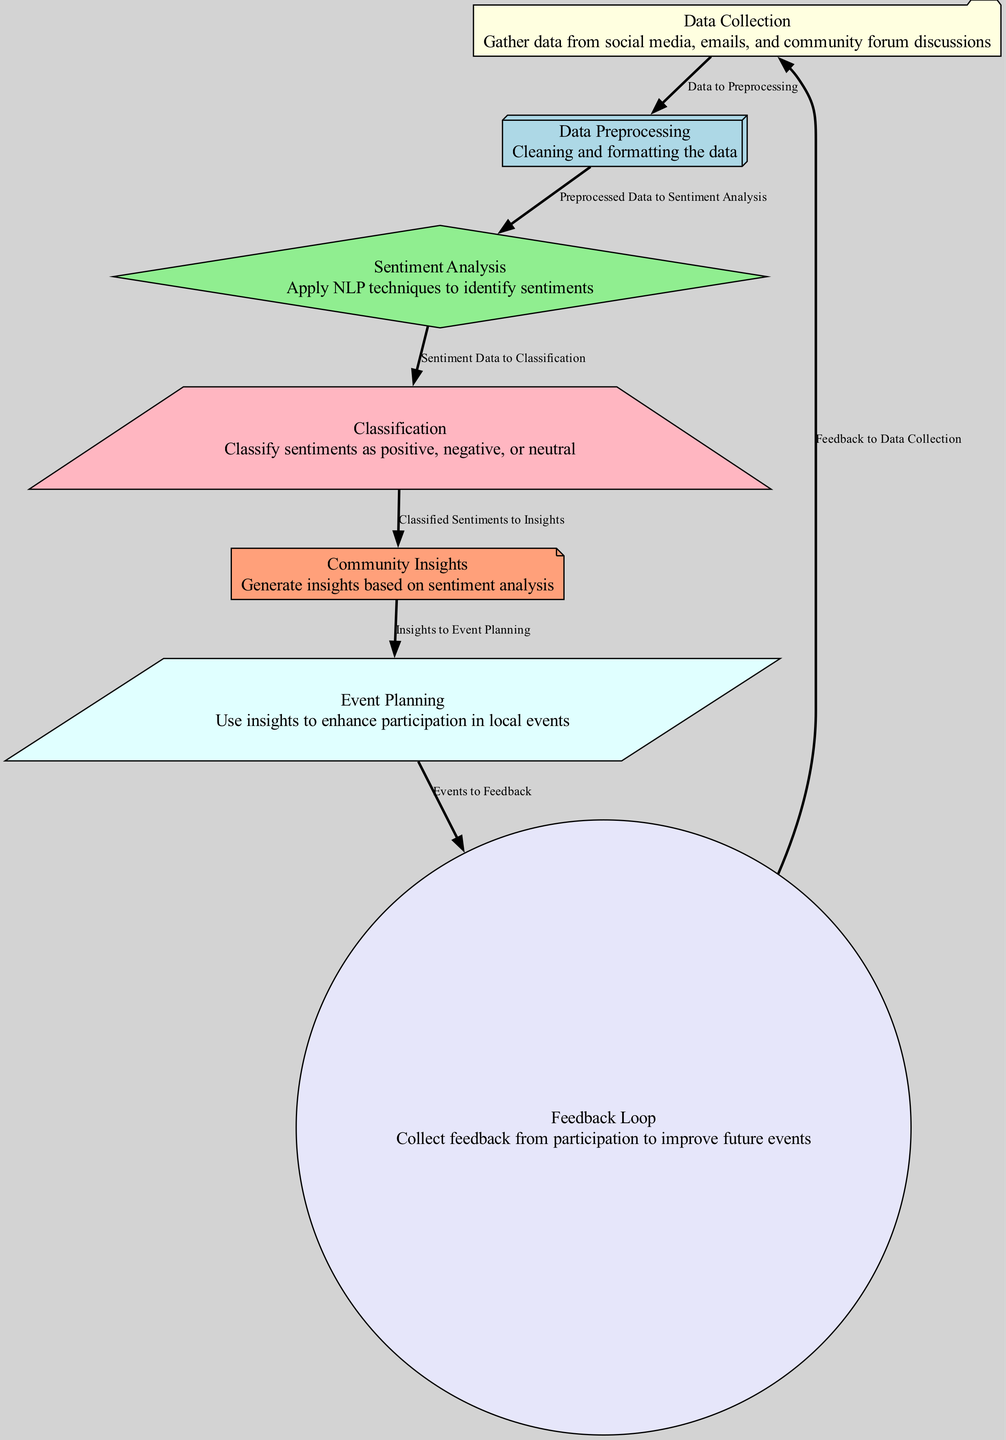What is the first step in the process? The diagram lists the first node as "Data Collection," indicating that the first action is to gather data.
Answer: Data Collection How many nodes are in the diagram? By counting all the distinct elements labeled in the diagram, we find there are 7 nodes represented.
Answer: 7 What type of analysis is performed after data preprocessing? The diagram indicates that after data preprocessing, the next step involves "Sentiment Analysis." This identifies sentiments expressed in the data.
Answer: Sentiment Analysis Which node generates insights based on classified sentiments? The "Community Insights" node generates insights by utilizing the data that has been classified into positive, negative, or neutral sentiments.
Answer: Community Insights What is the relationship between the "Event Planning" and "Feedback Loop"? The diagram shows a directed edge from "Event Planning" to "Feedback Loop," signifying that feedback is collected based on the events planned.
Answer: Events to Feedback How do classified sentiments contribute to future actions? Classified sentiments are transitioned to insights, which inform the "Event Planning" node, demonstrating how understanding sentiments enhances local events.
Answer: Insights to Event Planning What node collects feedback to improve future events? The "Feedback Loop" directly indicates that it is responsible for collecting feedback regarding events to inform improvements for subsequent gatherings.
Answer: Feedback Loop What happens after collecting feedback from participation? Once feedback is collected, the feedback is looped back to "Data Collection," reinforcing an iterative approach to the community participation process.
Answer: Feedback to Data Collection What is the purpose of the "Classification" node? The "Classification" node serves to categorize the sentiments derived from the analysis into three categories: positive, negative, or neutral.
Answer: Classify sentiments as positive, negative, or neutral 